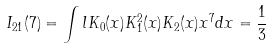<formula> <loc_0><loc_0><loc_500><loc_500>I _ { 2 1 } ( 7 ) = \int l K _ { 0 } ( x ) K _ { 1 } ^ { 2 } ( x ) K _ { 2 } ( x ) x ^ { 7 } d x = \frac { 1 } { 3 }</formula> 